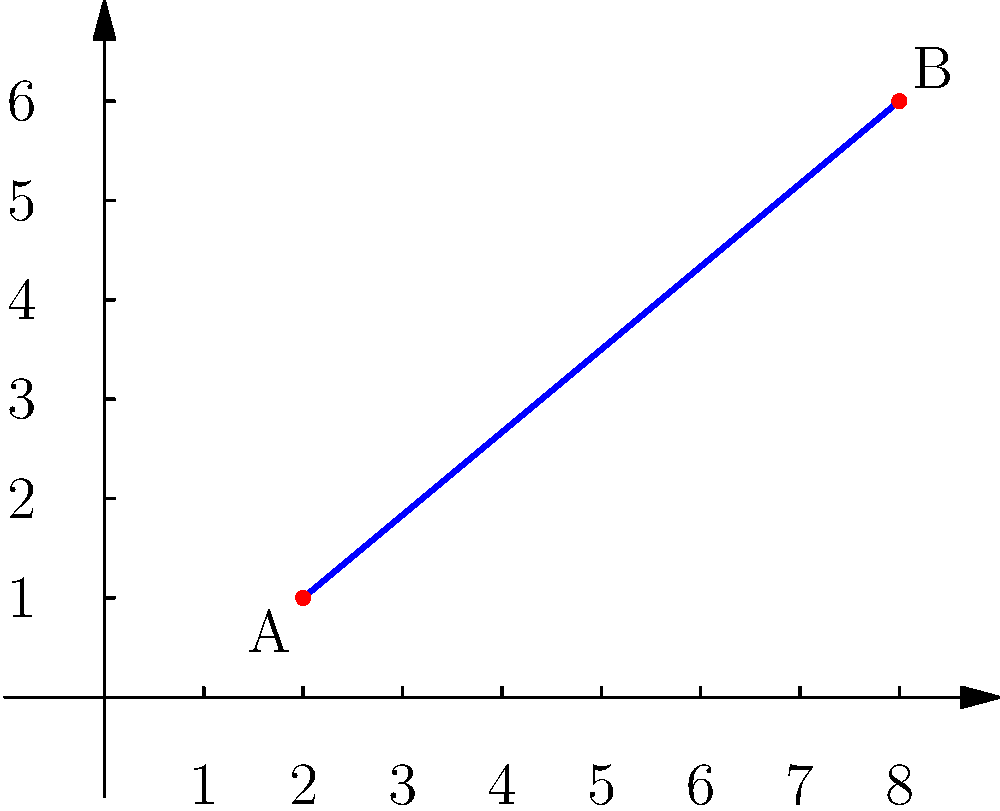In an animated sequence, a projectile travels from point A(2,1) to point B(8,6). To create a smooth transition effect, you need to find the midpoint of this trajectory. Calculate the coordinates of the midpoint M of line segment AB. To find the midpoint of a line segment, we can use the midpoint formula:

$$ M = (\frac{x_1 + x_2}{2}, \frac{y_1 + y_2}{2}) $$

Where $(x_1, y_1)$ are the coordinates of point A, and $(x_2, y_2)$ are the coordinates of point B.

Step 1: Identify the coordinates
A(2,1) and B(8,6)

Step 2: Apply the midpoint formula
$x$ coordinate of M: $\frac{x_1 + x_2}{2} = \frac{2 + 8}{2} = \frac{10}{2} = 5$
$y$ coordinate of M: $\frac{y_1 + y_2}{2} = \frac{1 + 6}{2} = \frac{7}{2} = 3.5$

Therefore, the coordinates of the midpoint M are (5, 3.5).
Answer: M(5, 3.5) 